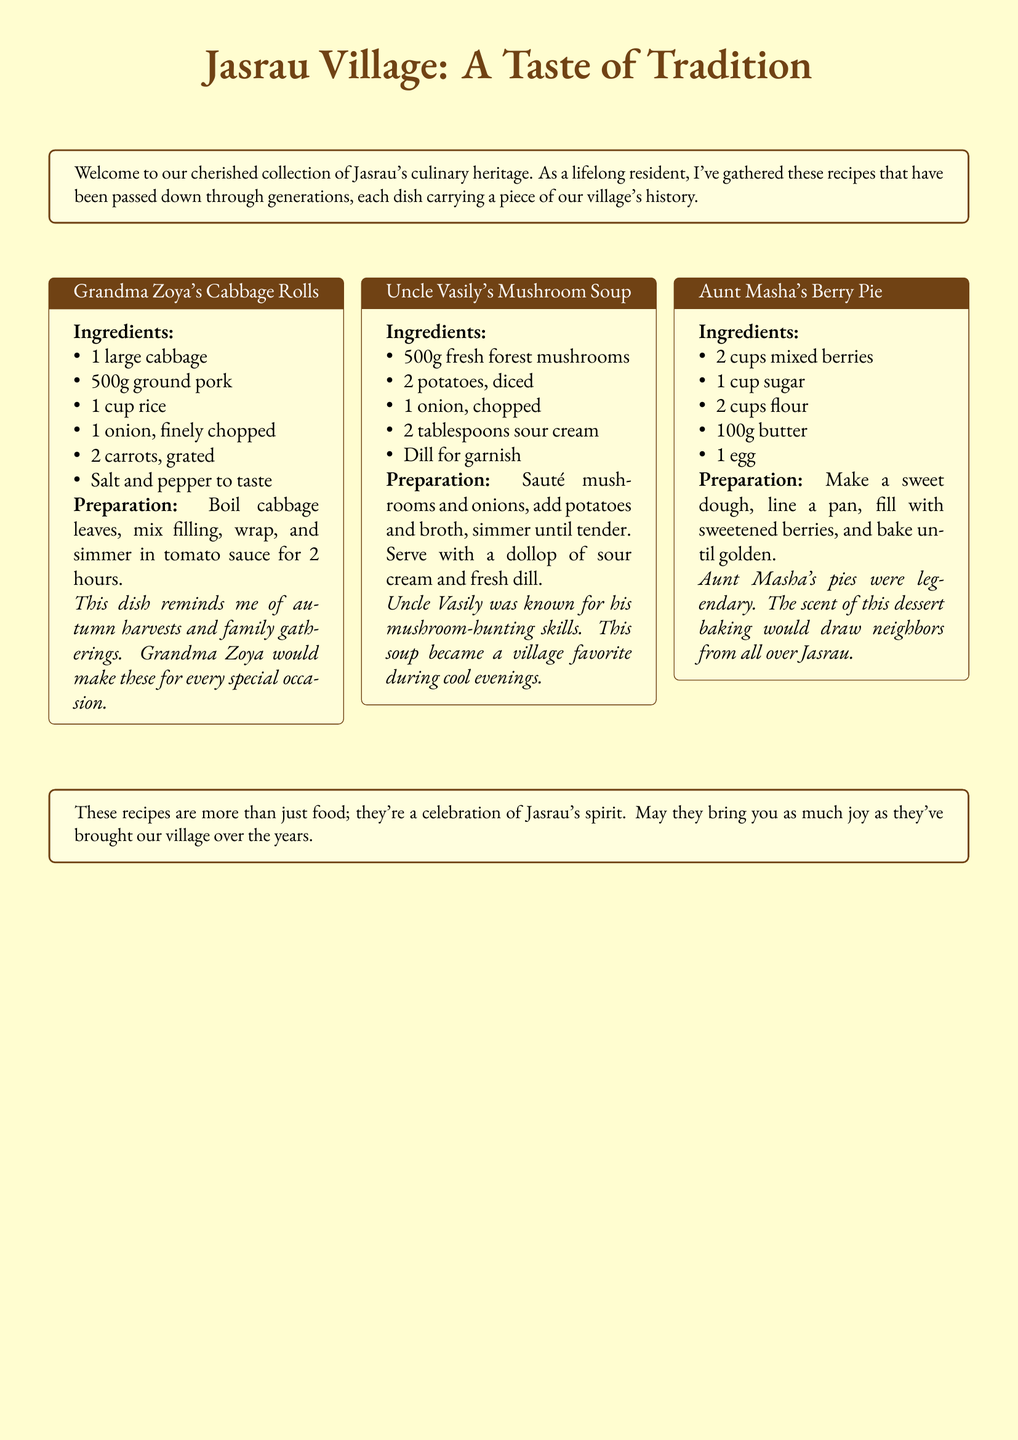What is the title of the first recipe? The title of the first recipe is mentioned in the document, specifically highlighted in the first tcolorbox.
Answer: Grandma Zoya's Cabbage Rolls How many ingredients are listed for Aunt Masha's Berry Pie? The number of ingredients can be counted in the list provided under Aunt Masha's Berry Pie recipe in the document.
Answer: 5 What filling is used in Grandma Zoya's Cabbage Rolls? The filling for Grandma Zoya's Cabbage Rolls is described under the preparation method in the document.
Answer: Ground pork Who is known for mushroom-hunting? Uncle Vasily is mentioned in the document as being known for his mushroom-hunting skills in his soup recipe description.
Answer: Uncle Vasily What is the primary ingredient in Uncle Vasily's Mushroom Soup? The primary ingredient is identified in the list of ingredients for Uncle Vasily's Mushroom Soup in the document.
Answer: Fresh forest mushrooms 